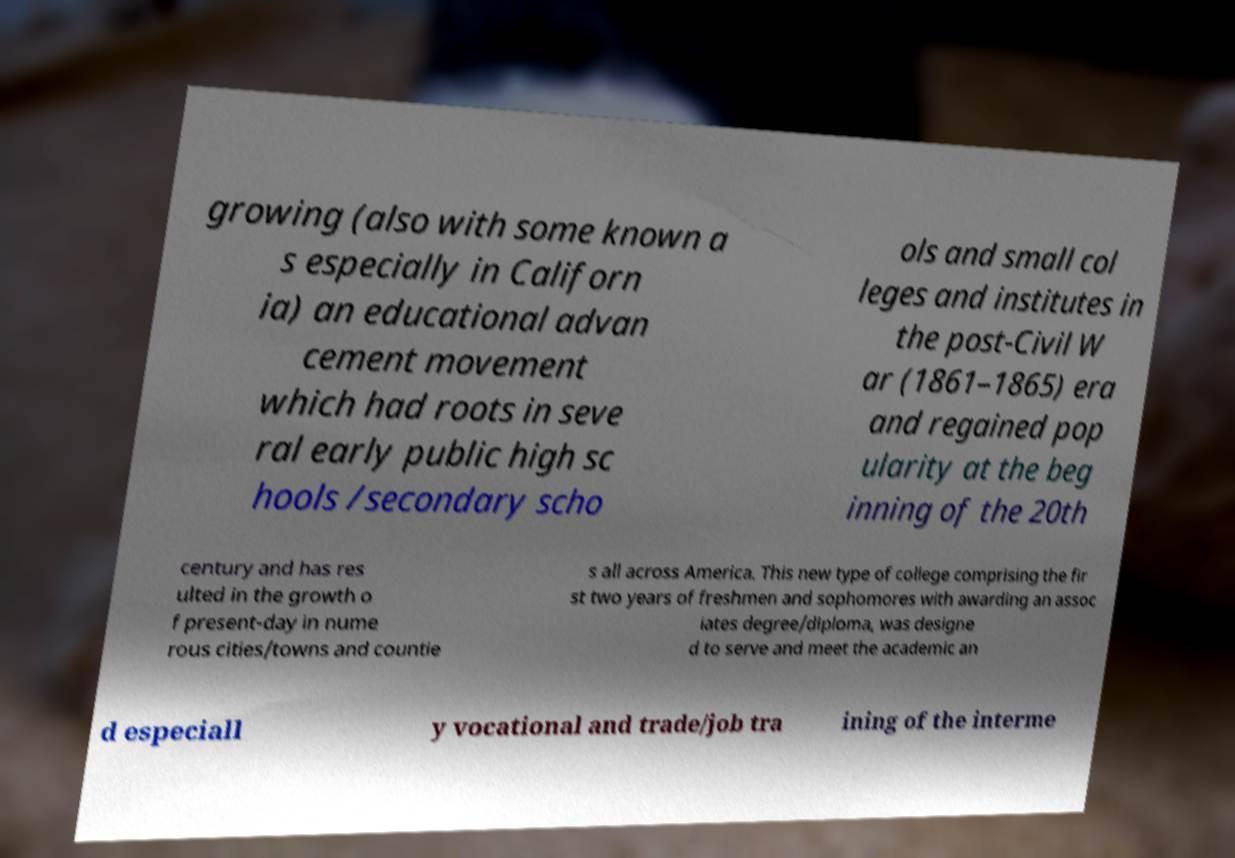Please identify and transcribe the text found in this image. growing (also with some known a s especially in Californ ia) an educational advan cement movement which had roots in seve ral early public high sc hools /secondary scho ols and small col leges and institutes in the post-Civil W ar (1861–1865) era and regained pop ularity at the beg inning of the 20th century and has res ulted in the growth o f present-day in nume rous cities/towns and countie s all across America. This new type of college comprising the fir st two years of freshmen and sophomores with awarding an assoc iates degree/diploma, was designe d to serve and meet the academic an d especiall y vocational and trade/job tra ining of the interme 